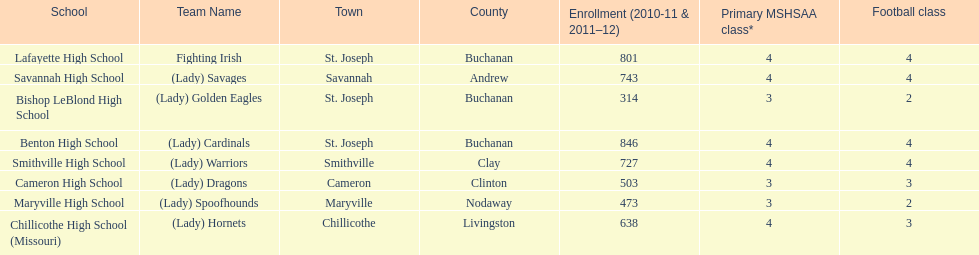How many of the schools had at least 500 students enrolled in the 2010-2011 and 2011-2012 season? 6. 